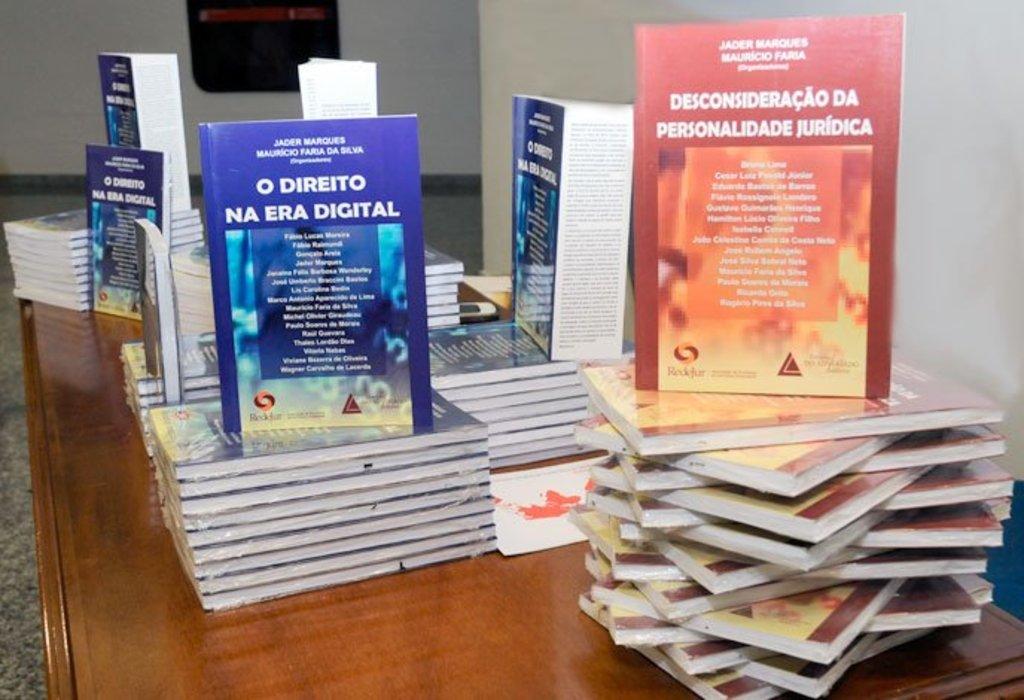What's the title of the book on the left?
Provide a succinct answer. O direito na era digital. 